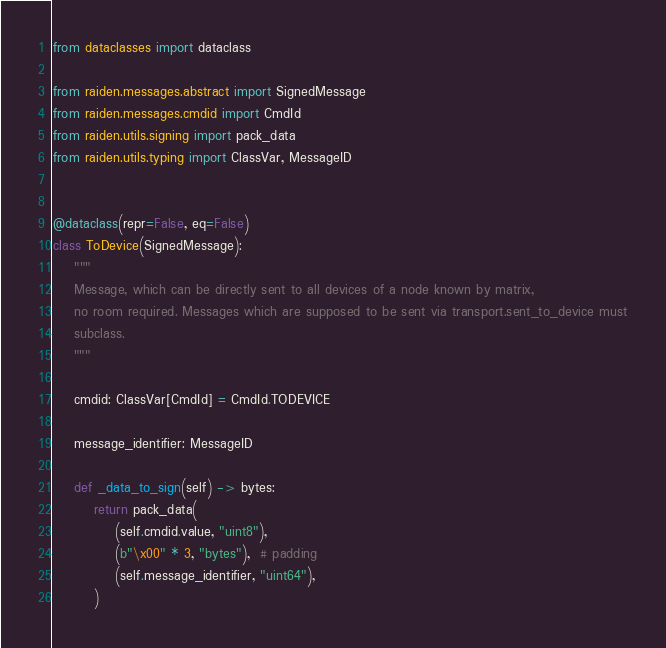<code> <loc_0><loc_0><loc_500><loc_500><_Python_>from dataclasses import dataclass

from raiden.messages.abstract import SignedMessage
from raiden.messages.cmdid import CmdId
from raiden.utils.signing import pack_data
from raiden.utils.typing import ClassVar, MessageID


@dataclass(repr=False, eq=False)
class ToDevice(SignedMessage):
    """
    Message, which can be directly sent to all devices of a node known by matrix,
    no room required. Messages which are supposed to be sent via transport.sent_to_device must
    subclass.
    """

    cmdid: ClassVar[CmdId] = CmdId.TODEVICE

    message_identifier: MessageID

    def _data_to_sign(self) -> bytes:
        return pack_data(
            (self.cmdid.value, "uint8"),
            (b"\x00" * 3, "bytes"),  # padding
            (self.message_identifier, "uint64"),
        )
</code> 